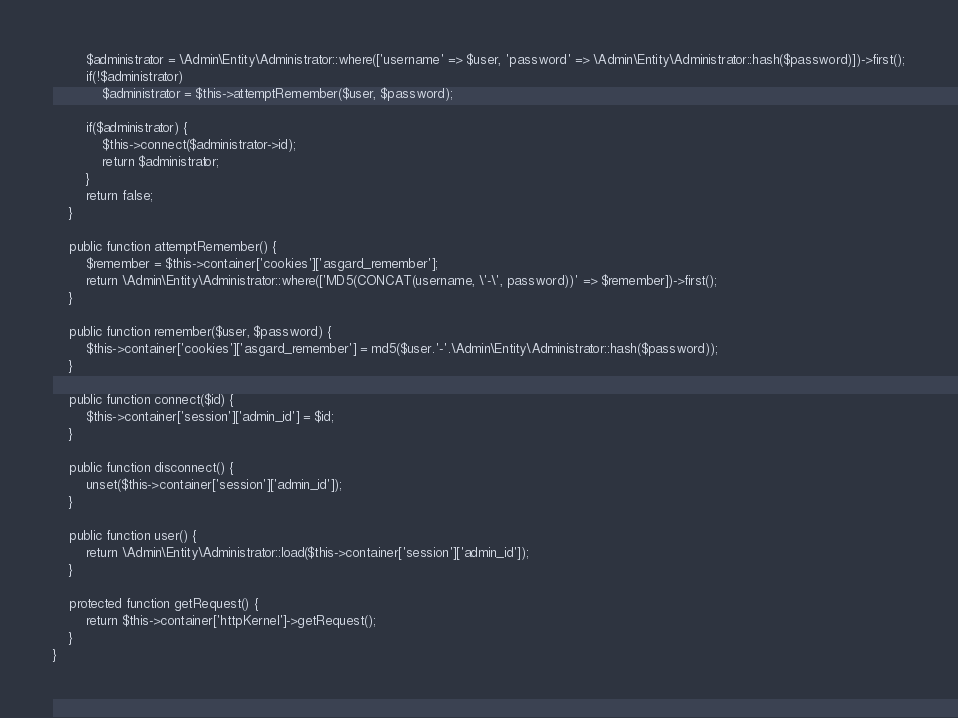Convert code to text. <code><loc_0><loc_0><loc_500><loc_500><_PHP_>		$administrator = \Admin\Entity\Administrator::where(['username' => $user, 'password' => \Admin\Entity\Administrator::hash($password)])->first();
		if(!$administrator)
			$administrator = $this->attemptRemember($user, $password);
		
		if($administrator) {
			$this->connect($administrator->id);
			return $administrator;
		}
		return false;
	}

	public function attemptRemember() {
		$remember = $this->container['cookies']['asgard_remember'];
		return \Admin\Entity\Administrator::where(['MD5(CONCAT(username, \'-\', password))' => $remember])->first();
	}

	public function remember($user, $password) {
		$this->container['cookies']['asgard_remember'] = md5($user.'-'.\Admin\Entity\Administrator::hash($password));
	}

	public function connect($id) {
		$this->container['session']['admin_id'] = $id;
	}

	public function disconnect() {
		unset($this->container['session']['admin_id']);
	}
	
	public function user() {
		return \Admin\Entity\Administrator::load($this->container['session']['admin_id']);
	}

	protected function getRequest() {
		return $this->container['httpKernel']->getRequest();
	}
}</code> 